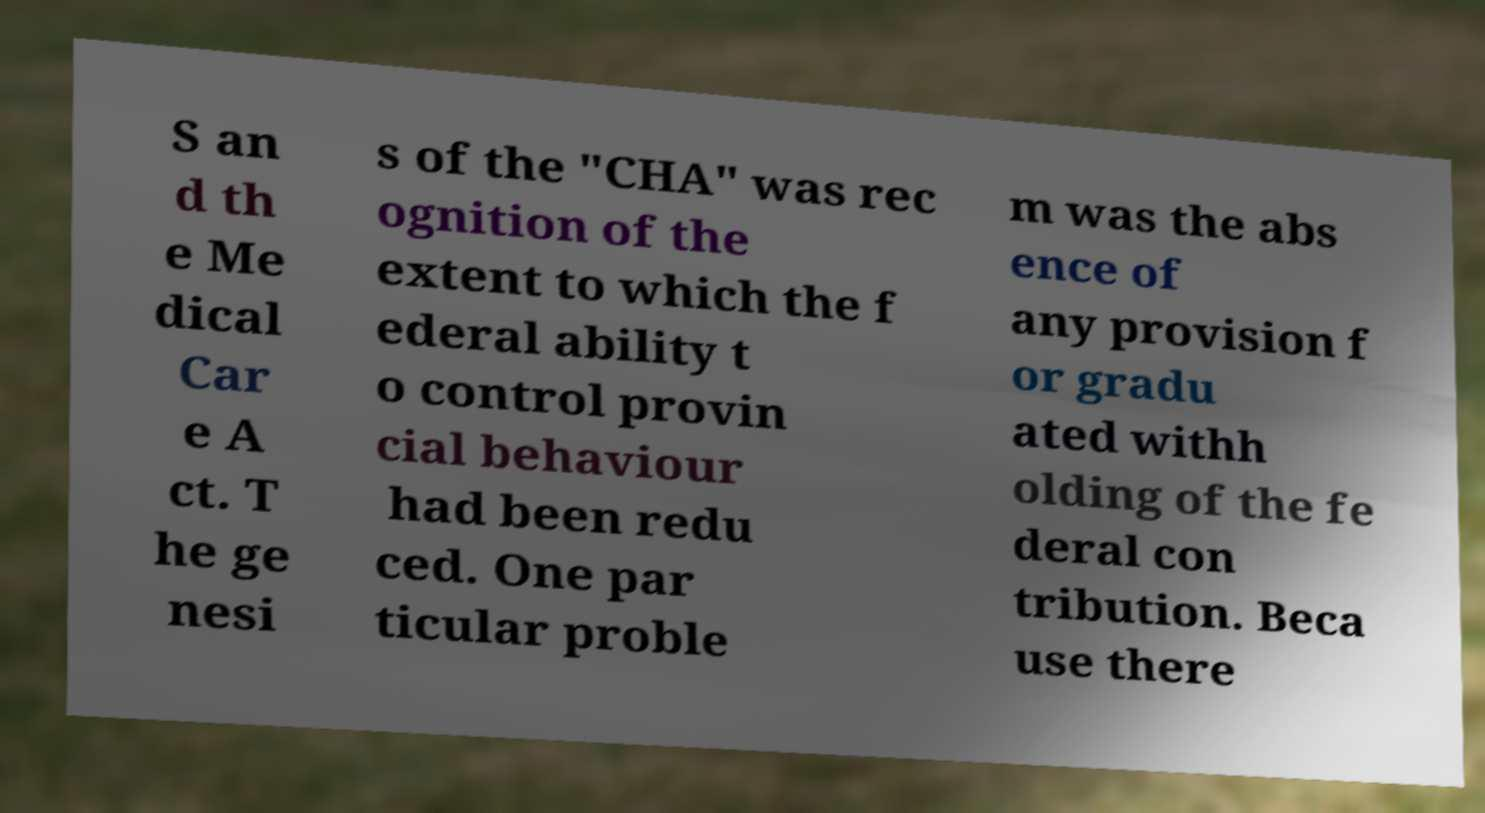Could you assist in decoding the text presented in this image and type it out clearly? S an d th e Me dical Car e A ct. T he ge nesi s of the "CHA" was rec ognition of the extent to which the f ederal ability t o control provin cial behaviour had been redu ced. One par ticular proble m was the abs ence of any provision f or gradu ated withh olding of the fe deral con tribution. Beca use there 